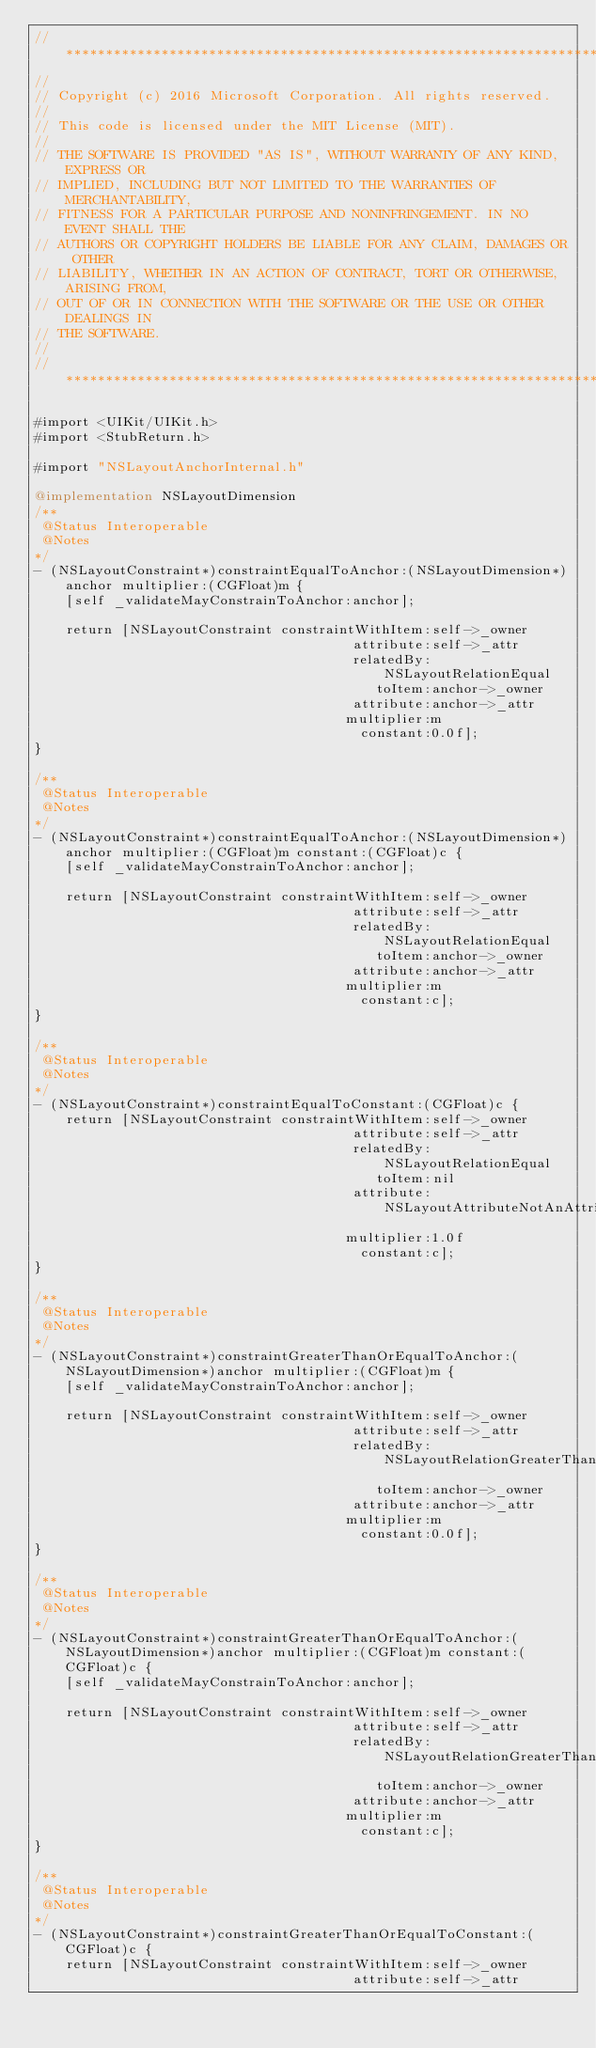Convert code to text. <code><loc_0><loc_0><loc_500><loc_500><_ObjectiveC_>//******************************************************************************
//
// Copyright (c) 2016 Microsoft Corporation. All rights reserved.
//
// This code is licensed under the MIT License (MIT).
//
// THE SOFTWARE IS PROVIDED "AS IS", WITHOUT WARRANTY OF ANY KIND, EXPRESS OR
// IMPLIED, INCLUDING BUT NOT LIMITED TO THE WARRANTIES OF MERCHANTABILITY,
// FITNESS FOR A PARTICULAR PURPOSE AND NONINFRINGEMENT. IN NO EVENT SHALL THE
// AUTHORS OR COPYRIGHT HOLDERS BE LIABLE FOR ANY CLAIM, DAMAGES OR OTHER
// LIABILITY, WHETHER IN AN ACTION OF CONTRACT, TORT OR OTHERWISE, ARISING FROM,
// OUT OF OR IN CONNECTION WITH THE SOFTWARE OR THE USE OR OTHER DEALINGS IN
// THE SOFTWARE.
//
//******************************************************************************

#import <UIKit/UIKit.h>
#import <StubReturn.h>

#import "NSLayoutAnchorInternal.h"

@implementation NSLayoutDimension
/**
 @Status Interoperable
 @Notes
*/
- (NSLayoutConstraint*)constraintEqualToAnchor:(NSLayoutDimension*)anchor multiplier:(CGFloat)m {
    [self _validateMayConstrainToAnchor:anchor];

    return [NSLayoutConstraint constraintWithItem:self->_owner 
                                        attribute:self->_attr 
                                        relatedBy:NSLayoutRelationEqual
                                           toItem:anchor->_owner
                                        attribute:anchor->_attr
                                       multiplier:m
                                         constant:0.0f];
}

/**
 @Status Interoperable
 @Notes
*/
- (NSLayoutConstraint*)constraintEqualToAnchor:(NSLayoutDimension*)anchor multiplier:(CGFloat)m constant:(CGFloat)c {
    [self _validateMayConstrainToAnchor:anchor];

    return [NSLayoutConstraint constraintWithItem:self->_owner 
                                        attribute:self->_attr 
                                        relatedBy:NSLayoutRelationEqual
                                           toItem:anchor->_owner
                                        attribute:anchor->_attr
                                       multiplier:m
                                         constant:c];
}

/**
 @Status Interoperable
 @Notes
*/
- (NSLayoutConstraint*)constraintEqualToConstant:(CGFloat)c {
    return [NSLayoutConstraint constraintWithItem:self->_owner 
                                        attribute:self->_attr 
                                        relatedBy:NSLayoutRelationEqual
                                           toItem:nil
                                        attribute:NSLayoutAttributeNotAnAttribute
                                       multiplier:1.0f
                                         constant:c];
}

/**
 @Status Interoperable
 @Notes
*/
- (NSLayoutConstraint*)constraintGreaterThanOrEqualToAnchor:(NSLayoutDimension*)anchor multiplier:(CGFloat)m {
    [self _validateMayConstrainToAnchor:anchor];

    return [NSLayoutConstraint constraintWithItem:self->_owner 
                                        attribute:self->_attr 
                                        relatedBy:NSLayoutRelationGreaterThanOrEqual
                                           toItem:anchor->_owner
                                        attribute:anchor->_attr
                                       multiplier:m
                                         constant:0.0f];
}

/**
 @Status Interoperable
 @Notes
*/
- (NSLayoutConstraint*)constraintGreaterThanOrEqualToAnchor:(NSLayoutDimension*)anchor multiplier:(CGFloat)m constant:(CGFloat)c {
    [self _validateMayConstrainToAnchor:anchor];

    return [NSLayoutConstraint constraintWithItem:self->_owner 
                                        attribute:self->_attr 
                                        relatedBy:NSLayoutRelationGreaterThanOrEqual
                                           toItem:anchor->_owner
                                        attribute:anchor->_attr
                                       multiplier:m
                                         constant:c];
}

/**
 @Status Interoperable
 @Notes
*/
- (NSLayoutConstraint*)constraintGreaterThanOrEqualToConstant:(CGFloat)c {
    return [NSLayoutConstraint constraintWithItem:self->_owner 
                                        attribute:self->_attr </code> 